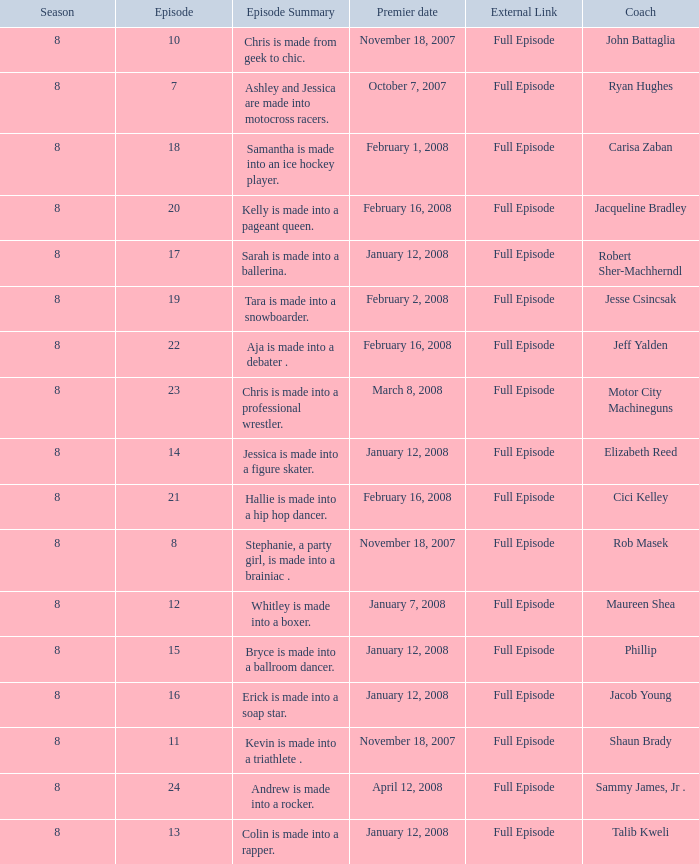Which Maximum episode premiered March 8, 2008? 23.0. 